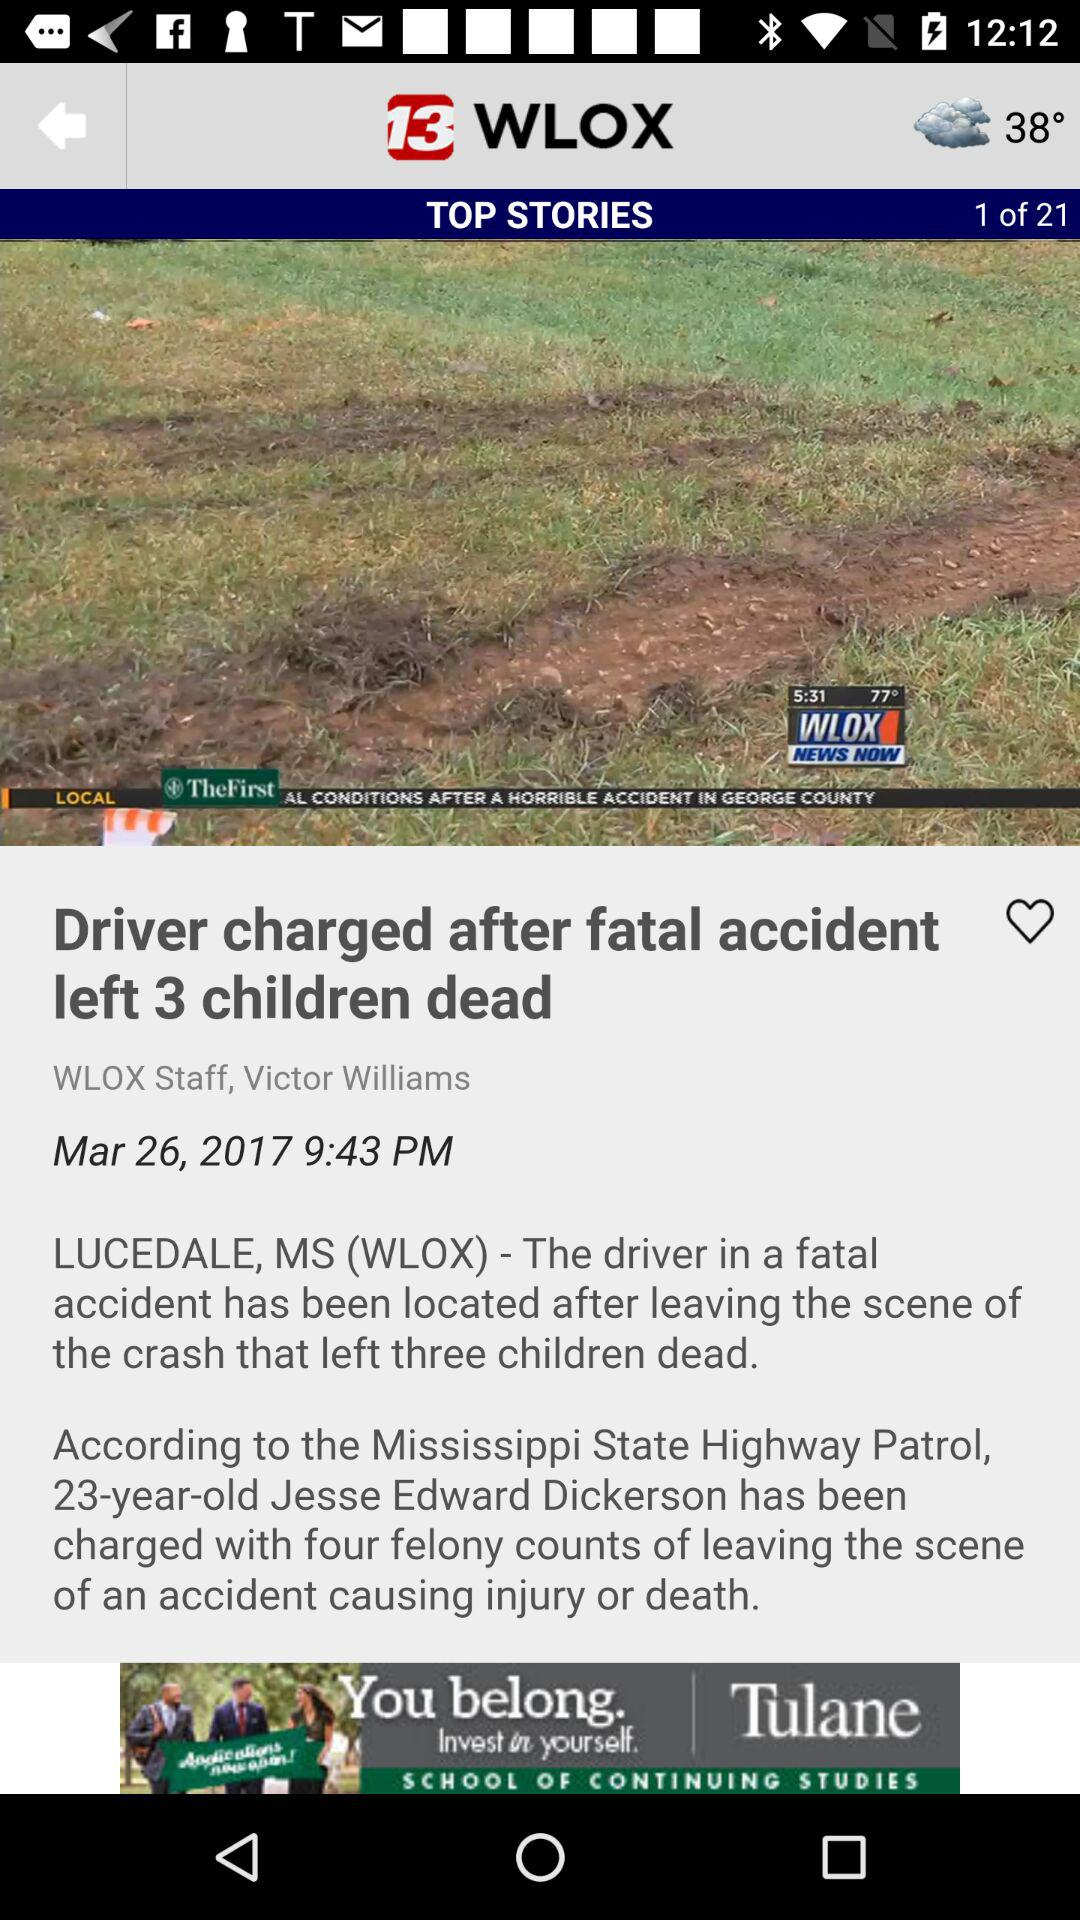What's the current temperature? The current temperature is 38°. 